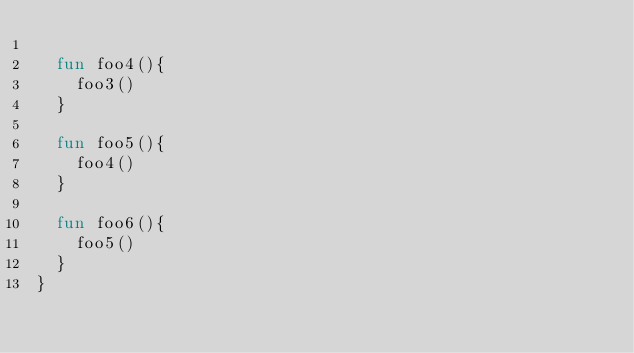<code> <loc_0><loc_0><loc_500><loc_500><_Kotlin_>
  fun foo4(){
    foo3()
  }

  fun foo5(){
    foo4()
  }

  fun foo6(){
    foo5()
  }
}</code> 